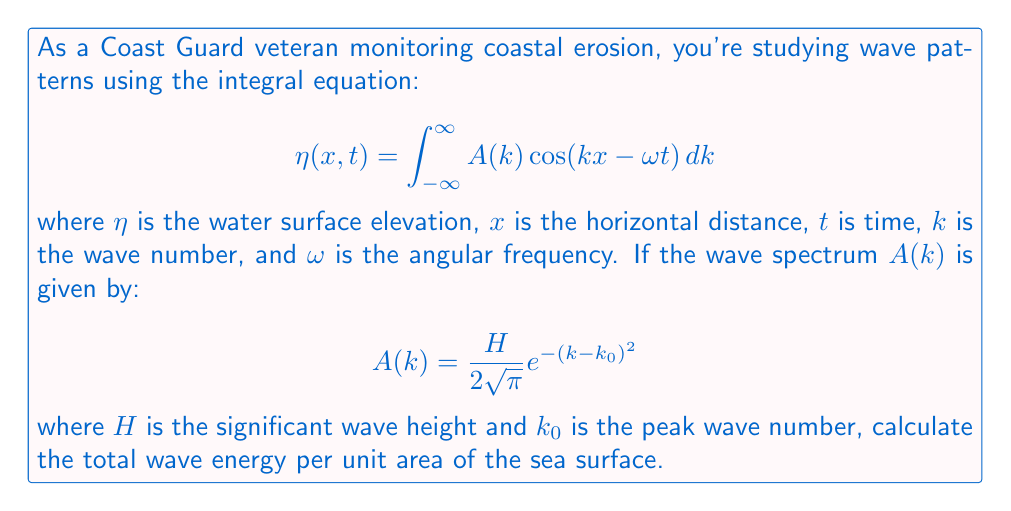What is the answer to this math problem? Let's approach this step-by-step:

1) The total wave energy per unit area of the sea surface is given by:

   $$E = \frac{1}{2}\rho g \int_{-\infty}^{\infty} |\eta(x,t)|^2 dx$$

   where $\rho$ is the water density and $g$ is the acceleration due to gravity.

2) Substituting the expression for $\eta(x,t)$:

   $$E = \frac{1}{2}\rho g \int_{-\infty}^{\infty} \left|\int_{-\infty}^{\infty} A(k) \cos(kx - \omega t) dk\right|^2 dx$$

3) Using Parseval's theorem, this can be simplified to:

   $$E = \frac{1}{2}\rho g \int_{-\infty}^{\infty} |A(k)|^2 dk$$

4) Now, let's substitute the given wave spectrum:

   $$E = \frac{1}{2}\rho g \int_{-\infty}^{\infty} \left(\frac{H}{2\sqrt{\pi}} e^{-(k-k_0)^2}\right)^2 dk$$

5) Simplifying:

   $$E = \frac{1}{2}\rho g \frac{H^2}{16\pi} \int_{-\infty}^{\infty} e^{-2(k-k_0)^2} dk$$

6) This integral is a standard Gaussian integral with a known solution:

   $$\int_{-\infty}^{\infty} e^{-ax^2} dx = \sqrt{\frac{\pi}{a}}$$

   In our case, $a = 2$, so:

   $$E = \frac{1}{2}\rho g \frac{H^2}{16\pi} \sqrt{\frac{\pi}{2}} = \frac{1}{16\sqrt{2}}\rho g H^2$$

Therefore, the total wave energy per unit area of the sea surface is $\frac{1}{16\sqrt{2}}\rho g H^2$.
Answer: $\frac{1}{16\sqrt{2}}\rho g H^2$ 